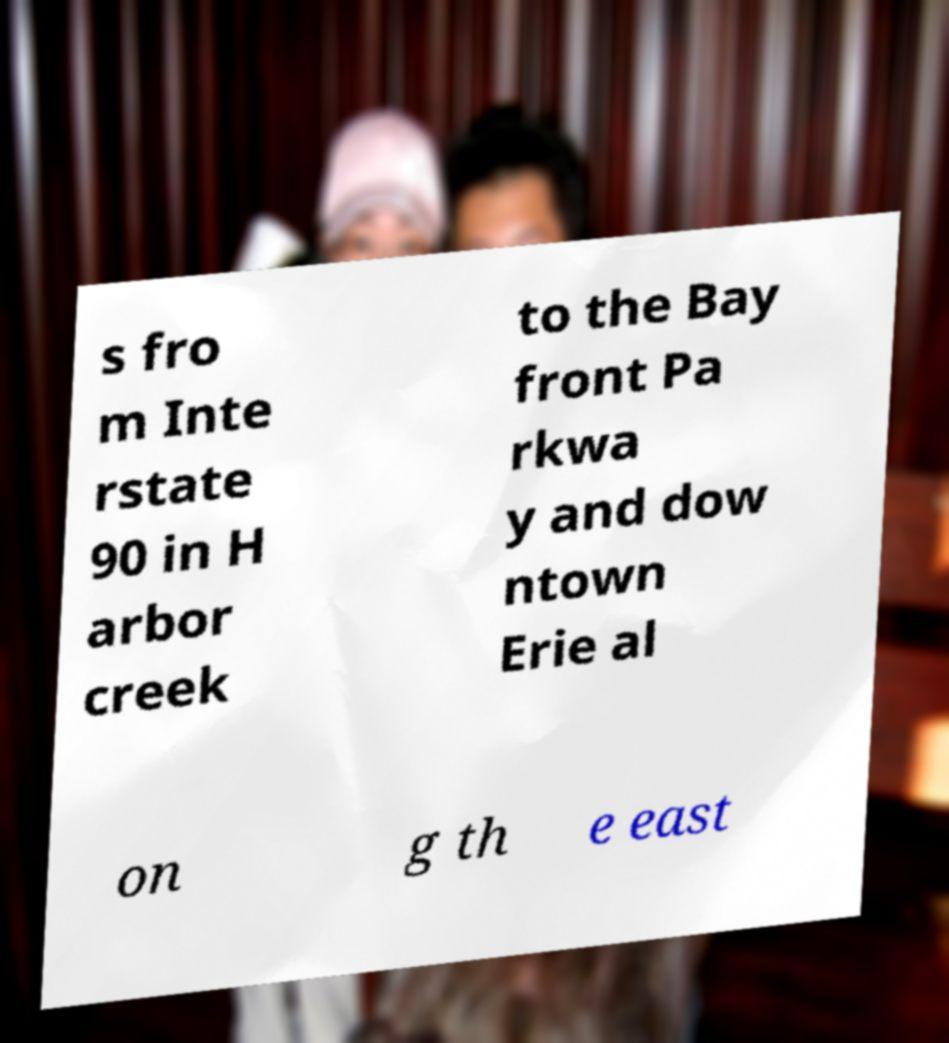What messages or text are displayed in this image? I need them in a readable, typed format. s fro m Inte rstate 90 in H arbor creek to the Bay front Pa rkwa y and dow ntown Erie al on g th e east 